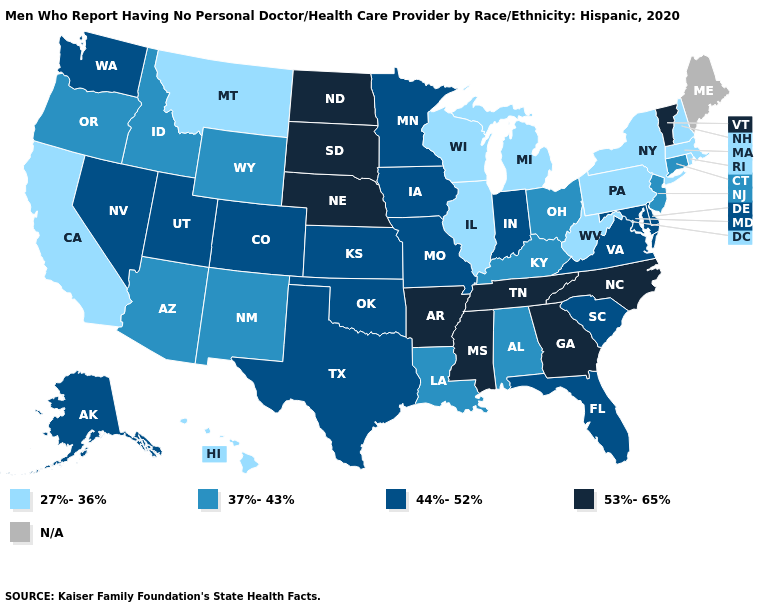What is the value of Iowa?
Keep it brief. 44%-52%. What is the value of Minnesota?
Short answer required. 44%-52%. What is the lowest value in the MidWest?
Short answer required. 27%-36%. Name the states that have a value in the range 27%-36%?
Give a very brief answer. California, Hawaii, Illinois, Massachusetts, Michigan, Montana, New Hampshire, New York, Pennsylvania, Rhode Island, West Virginia, Wisconsin. Does Connecticut have the highest value in the Northeast?
Give a very brief answer. No. What is the highest value in states that border Maryland?
Keep it brief. 44%-52%. What is the lowest value in the USA?
Be succinct. 27%-36%. Does the first symbol in the legend represent the smallest category?
Concise answer only. Yes. Among the states that border Wyoming , which have the highest value?
Give a very brief answer. Nebraska, South Dakota. Which states hav the highest value in the West?
Write a very short answer. Alaska, Colorado, Nevada, Utah, Washington. What is the lowest value in states that border Arkansas?
Short answer required. 37%-43%. Name the states that have a value in the range 44%-52%?
Write a very short answer. Alaska, Colorado, Delaware, Florida, Indiana, Iowa, Kansas, Maryland, Minnesota, Missouri, Nevada, Oklahoma, South Carolina, Texas, Utah, Virginia, Washington. Does Mississippi have the lowest value in the USA?
Be succinct. No. Name the states that have a value in the range 44%-52%?
Answer briefly. Alaska, Colorado, Delaware, Florida, Indiana, Iowa, Kansas, Maryland, Minnesota, Missouri, Nevada, Oklahoma, South Carolina, Texas, Utah, Virginia, Washington. 